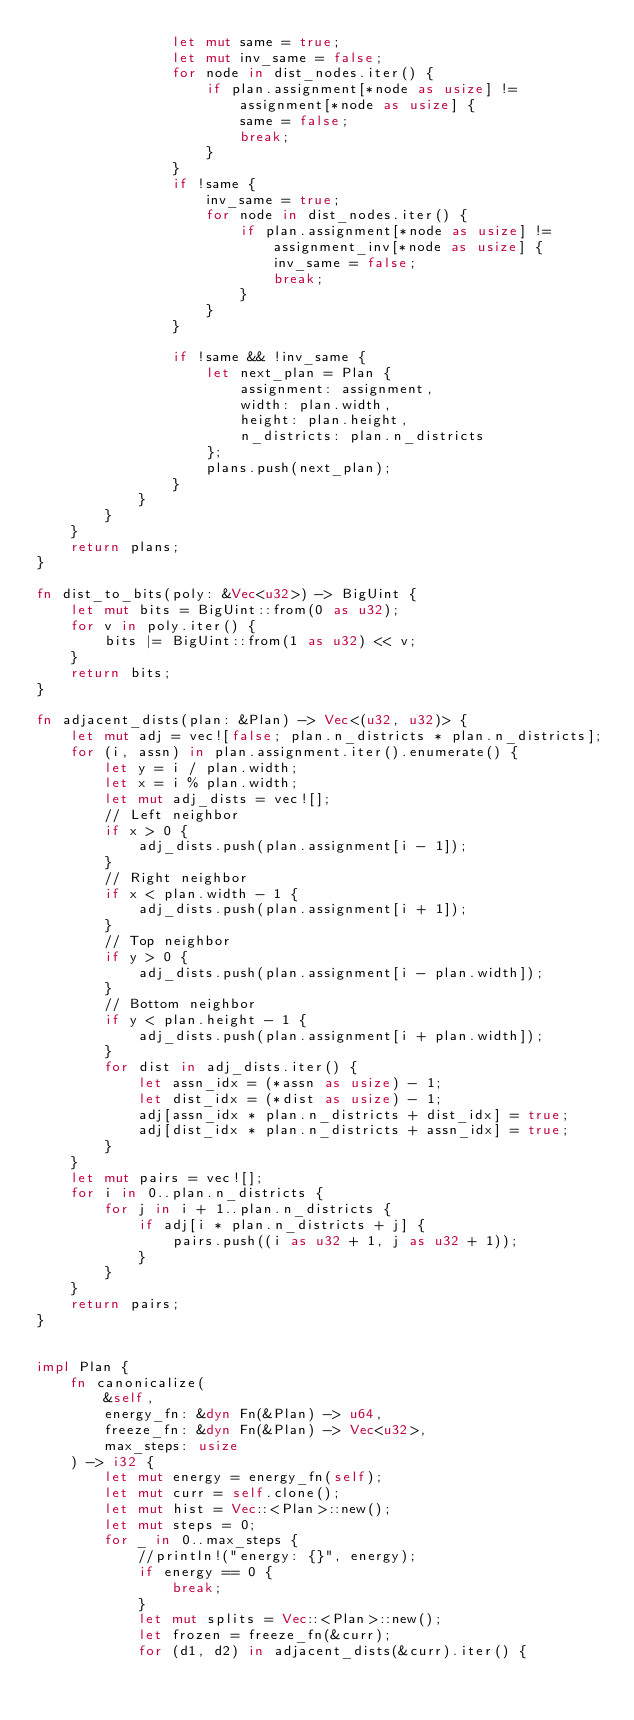Convert code to text. <code><loc_0><loc_0><loc_500><loc_500><_Rust_>                let mut same = true;
                let mut inv_same = false;
                for node in dist_nodes.iter() {
                    if plan.assignment[*node as usize] != assignment[*node as usize] {
                        same = false;
                        break;
                    }
                }
                if !same {
                    inv_same = true;
                    for node in dist_nodes.iter() {
                        if plan.assignment[*node as usize] != assignment_inv[*node as usize] {
                            inv_same = false;
                            break;
                        }
                    }
                }

                if !same && !inv_same {
                    let next_plan = Plan {
                        assignment: assignment,
                        width: plan.width,
                        height: plan.height,
                        n_districts: plan.n_districts
                    };
                    plans.push(next_plan);
                }
            }
        }
    }
    return plans;
}

fn dist_to_bits(poly: &Vec<u32>) -> BigUint {
    let mut bits = BigUint::from(0 as u32);
    for v in poly.iter() {
        bits |= BigUint::from(1 as u32) << v;
    }
    return bits;
}

fn adjacent_dists(plan: &Plan) -> Vec<(u32, u32)> {
    let mut adj = vec![false; plan.n_districts * plan.n_districts];
    for (i, assn) in plan.assignment.iter().enumerate() {
        let y = i / plan.width;
        let x = i % plan.width;
        let mut adj_dists = vec![];
        // Left neighbor
        if x > 0 {
            adj_dists.push(plan.assignment[i - 1]);
        }
        // Right neighbor
        if x < plan.width - 1 {
            adj_dists.push(plan.assignment[i + 1]);
        }
        // Top neighbor
        if y > 0 {
            adj_dists.push(plan.assignment[i - plan.width]);
        }
        // Bottom neighbor
        if y < plan.height - 1 {
            adj_dists.push(plan.assignment[i + plan.width]);
        }
        for dist in adj_dists.iter() {
            let assn_idx = (*assn as usize) - 1;
            let dist_idx = (*dist as usize) - 1;
            adj[assn_idx * plan.n_districts + dist_idx] = true;
            adj[dist_idx * plan.n_districts + assn_idx] = true;
        }
    }
    let mut pairs = vec![];
    for i in 0..plan.n_districts {
        for j in i + 1..plan.n_districts {
            if adj[i * plan.n_districts + j] {
                pairs.push((i as u32 + 1, j as u32 + 1));
            }
        }
    }
    return pairs;
}


impl Plan {
    fn canonicalize(
        &self,
        energy_fn: &dyn Fn(&Plan) -> u64,
        freeze_fn: &dyn Fn(&Plan) -> Vec<u32>,
        max_steps: usize
    ) -> i32 {
        let mut energy = energy_fn(self);
        let mut curr = self.clone();
        let mut hist = Vec::<Plan>::new();
        let mut steps = 0;
        for _ in 0..max_steps {
            //println!("energy: {}", energy);
            if energy == 0 {
                break;
            }
            let mut splits = Vec::<Plan>::new();
            let frozen = freeze_fn(&curr);
            for (d1, d2) in adjacent_dists(&curr).iter() {</code> 